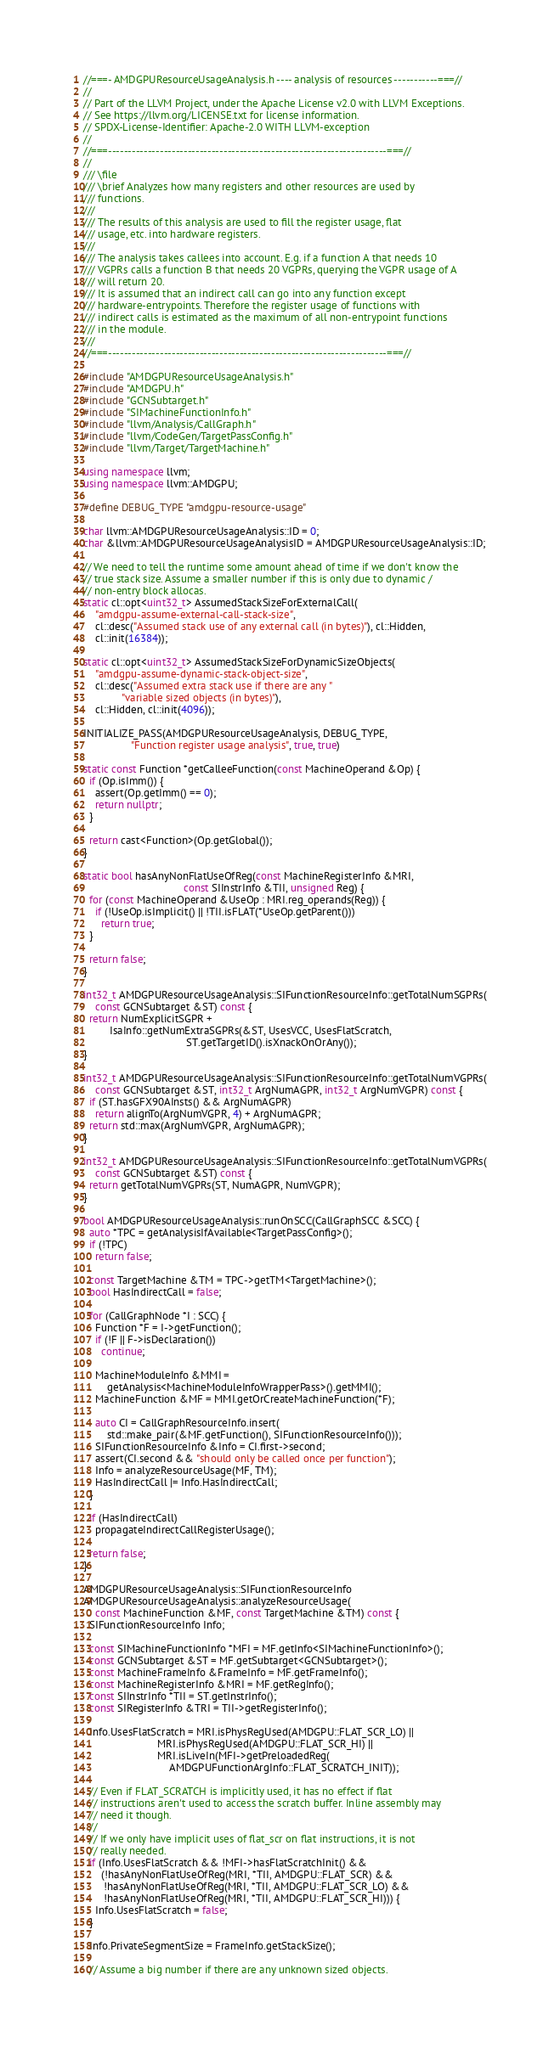Convert code to text. <code><loc_0><loc_0><loc_500><loc_500><_C++_>//===- AMDGPUResourceUsageAnalysis.h ---- analysis of resources -----------===//
//
// Part of the LLVM Project, under the Apache License v2.0 with LLVM Exceptions.
// See https://llvm.org/LICENSE.txt for license information.
// SPDX-License-Identifier: Apache-2.0 WITH LLVM-exception
//
//===----------------------------------------------------------------------===//
//
/// \file
/// \brief Analyzes how many registers and other resources are used by
/// functions.
///
/// The results of this analysis are used to fill the register usage, flat
/// usage, etc. into hardware registers.
///
/// The analysis takes callees into account. E.g. if a function A that needs 10
/// VGPRs calls a function B that needs 20 VGPRs, querying the VGPR usage of A
/// will return 20.
/// It is assumed that an indirect call can go into any function except
/// hardware-entrypoints. Therefore the register usage of functions with
/// indirect calls is estimated as the maximum of all non-entrypoint functions
/// in the module.
///
//===----------------------------------------------------------------------===//

#include "AMDGPUResourceUsageAnalysis.h"
#include "AMDGPU.h"
#include "GCNSubtarget.h"
#include "SIMachineFunctionInfo.h"
#include "llvm/Analysis/CallGraph.h"
#include "llvm/CodeGen/TargetPassConfig.h"
#include "llvm/Target/TargetMachine.h"

using namespace llvm;
using namespace llvm::AMDGPU;

#define DEBUG_TYPE "amdgpu-resource-usage"

char llvm::AMDGPUResourceUsageAnalysis::ID = 0;
char &llvm::AMDGPUResourceUsageAnalysisID = AMDGPUResourceUsageAnalysis::ID;

// We need to tell the runtime some amount ahead of time if we don't know the
// true stack size. Assume a smaller number if this is only due to dynamic /
// non-entry block allocas.
static cl::opt<uint32_t> AssumedStackSizeForExternalCall(
    "amdgpu-assume-external-call-stack-size",
    cl::desc("Assumed stack use of any external call (in bytes)"), cl::Hidden,
    cl::init(16384));

static cl::opt<uint32_t> AssumedStackSizeForDynamicSizeObjects(
    "amdgpu-assume-dynamic-stack-object-size",
    cl::desc("Assumed extra stack use if there are any "
             "variable sized objects (in bytes)"),
    cl::Hidden, cl::init(4096));

INITIALIZE_PASS(AMDGPUResourceUsageAnalysis, DEBUG_TYPE,
                "Function register usage analysis", true, true)

static const Function *getCalleeFunction(const MachineOperand &Op) {
  if (Op.isImm()) {
    assert(Op.getImm() == 0);
    return nullptr;
  }

  return cast<Function>(Op.getGlobal());
}

static bool hasAnyNonFlatUseOfReg(const MachineRegisterInfo &MRI,
                                  const SIInstrInfo &TII, unsigned Reg) {
  for (const MachineOperand &UseOp : MRI.reg_operands(Reg)) {
    if (!UseOp.isImplicit() || !TII.isFLAT(*UseOp.getParent()))
      return true;
  }

  return false;
}

int32_t AMDGPUResourceUsageAnalysis::SIFunctionResourceInfo::getTotalNumSGPRs(
    const GCNSubtarget &ST) const {
  return NumExplicitSGPR +
         IsaInfo::getNumExtraSGPRs(&ST, UsesVCC, UsesFlatScratch,
                                   ST.getTargetID().isXnackOnOrAny());
}

int32_t AMDGPUResourceUsageAnalysis::SIFunctionResourceInfo::getTotalNumVGPRs(
    const GCNSubtarget &ST, int32_t ArgNumAGPR, int32_t ArgNumVGPR) const {
  if (ST.hasGFX90AInsts() && ArgNumAGPR)
    return alignTo(ArgNumVGPR, 4) + ArgNumAGPR;
  return std::max(ArgNumVGPR, ArgNumAGPR);
}

int32_t AMDGPUResourceUsageAnalysis::SIFunctionResourceInfo::getTotalNumVGPRs(
    const GCNSubtarget &ST) const {
  return getTotalNumVGPRs(ST, NumAGPR, NumVGPR);
}

bool AMDGPUResourceUsageAnalysis::runOnSCC(CallGraphSCC &SCC) {
  auto *TPC = getAnalysisIfAvailable<TargetPassConfig>();
  if (!TPC)
    return false;

  const TargetMachine &TM = TPC->getTM<TargetMachine>();
  bool HasIndirectCall = false;

  for (CallGraphNode *I : SCC) {
    Function *F = I->getFunction();
    if (!F || F->isDeclaration())
      continue;

    MachineModuleInfo &MMI =
        getAnalysis<MachineModuleInfoWrapperPass>().getMMI();
    MachineFunction &MF = MMI.getOrCreateMachineFunction(*F);

    auto CI = CallGraphResourceInfo.insert(
        std::make_pair(&MF.getFunction(), SIFunctionResourceInfo()));
    SIFunctionResourceInfo &Info = CI.first->second;
    assert(CI.second && "should only be called once per function");
    Info = analyzeResourceUsage(MF, TM);
    HasIndirectCall |= Info.HasIndirectCall;
  }

  if (HasIndirectCall)
    propagateIndirectCallRegisterUsage();

  return false;
}

AMDGPUResourceUsageAnalysis::SIFunctionResourceInfo
AMDGPUResourceUsageAnalysis::analyzeResourceUsage(
    const MachineFunction &MF, const TargetMachine &TM) const {
  SIFunctionResourceInfo Info;

  const SIMachineFunctionInfo *MFI = MF.getInfo<SIMachineFunctionInfo>();
  const GCNSubtarget &ST = MF.getSubtarget<GCNSubtarget>();
  const MachineFrameInfo &FrameInfo = MF.getFrameInfo();
  const MachineRegisterInfo &MRI = MF.getRegInfo();
  const SIInstrInfo *TII = ST.getInstrInfo();
  const SIRegisterInfo &TRI = TII->getRegisterInfo();

  Info.UsesFlatScratch = MRI.isPhysRegUsed(AMDGPU::FLAT_SCR_LO) ||
                         MRI.isPhysRegUsed(AMDGPU::FLAT_SCR_HI) ||
                         MRI.isLiveIn(MFI->getPreloadedReg(
                             AMDGPUFunctionArgInfo::FLAT_SCRATCH_INIT));

  // Even if FLAT_SCRATCH is implicitly used, it has no effect if flat
  // instructions aren't used to access the scratch buffer. Inline assembly may
  // need it though.
  //
  // If we only have implicit uses of flat_scr on flat instructions, it is not
  // really needed.
  if (Info.UsesFlatScratch && !MFI->hasFlatScratchInit() &&
      (!hasAnyNonFlatUseOfReg(MRI, *TII, AMDGPU::FLAT_SCR) &&
       !hasAnyNonFlatUseOfReg(MRI, *TII, AMDGPU::FLAT_SCR_LO) &&
       !hasAnyNonFlatUseOfReg(MRI, *TII, AMDGPU::FLAT_SCR_HI))) {
    Info.UsesFlatScratch = false;
  }

  Info.PrivateSegmentSize = FrameInfo.getStackSize();

  // Assume a big number if there are any unknown sized objects.</code> 